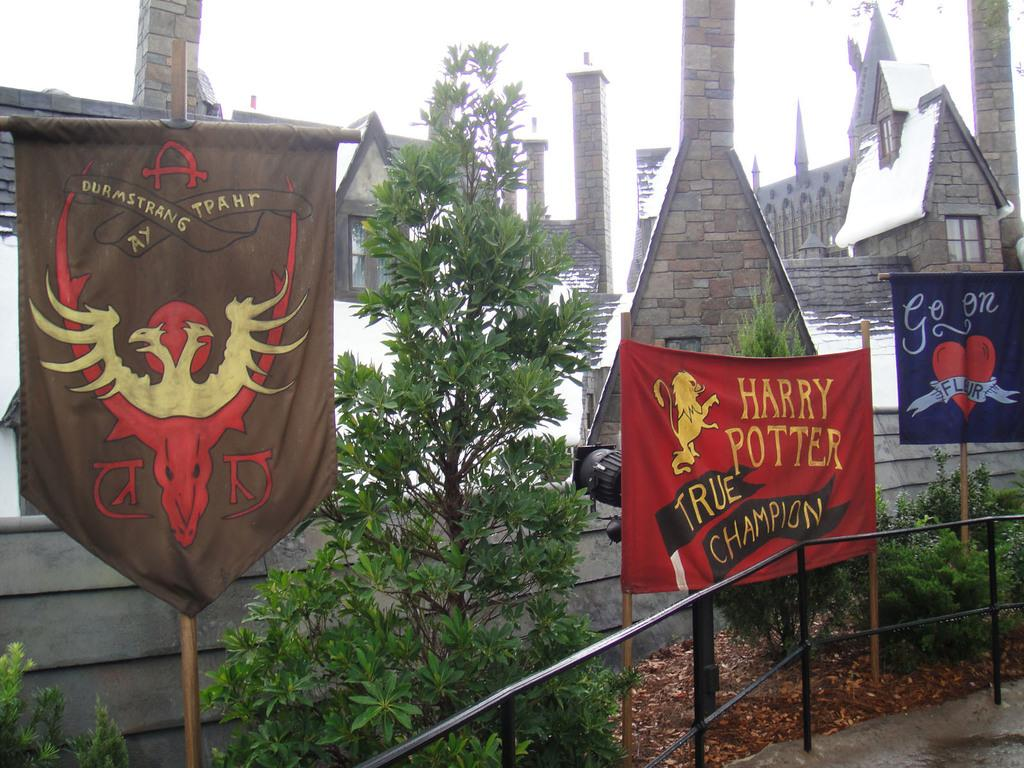<image>
Offer a succinct explanation of the picture presented. a walkway with a banner that says 'harry potter true champion' on it 